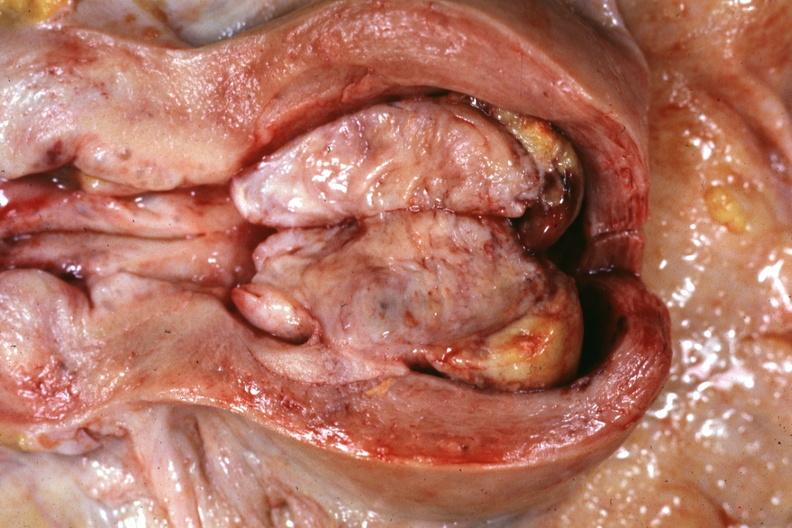s female reproductive present?
Answer the question using a single word or phrase. Yes 